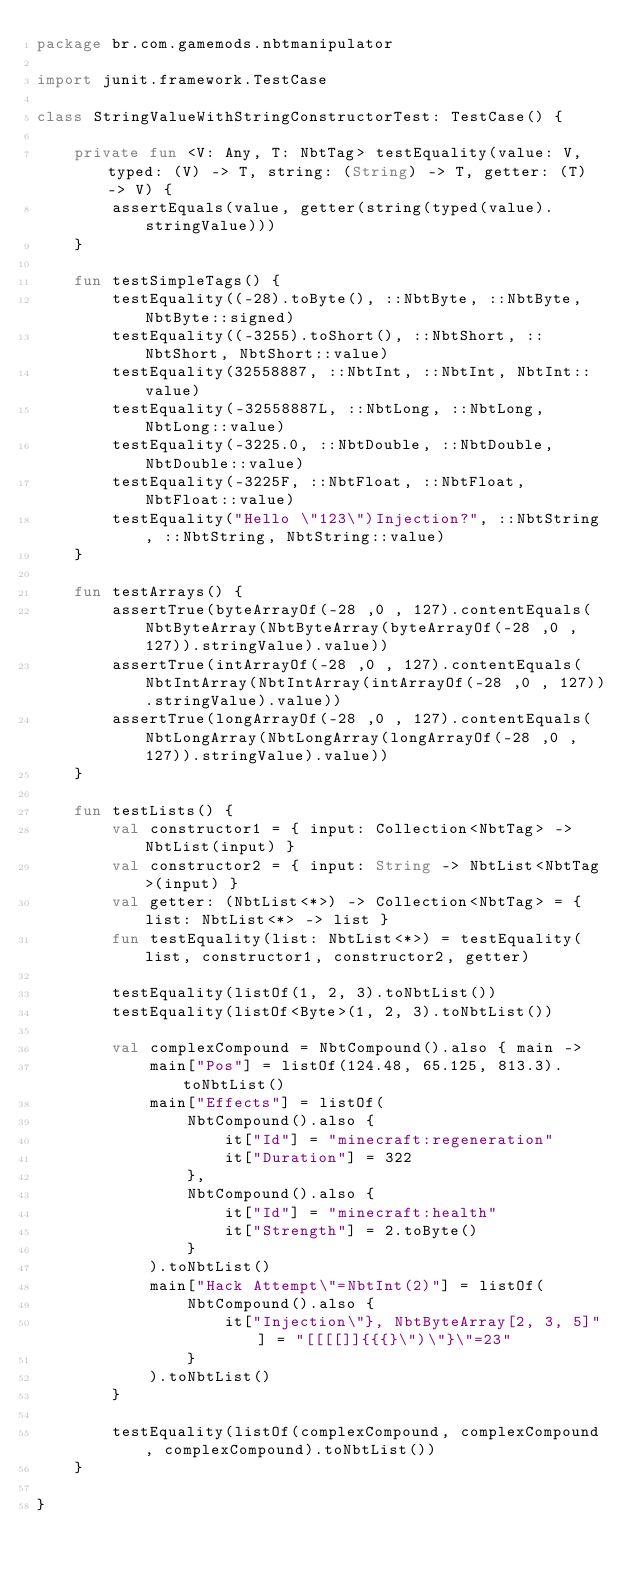<code> <loc_0><loc_0><loc_500><loc_500><_Kotlin_>package br.com.gamemods.nbtmanipulator

import junit.framework.TestCase

class StringValueWithStringConstructorTest: TestCase() {

    private fun <V: Any, T: NbtTag> testEquality(value: V, typed: (V) -> T, string: (String) -> T, getter: (T) -> V) {
        assertEquals(value, getter(string(typed(value).stringValue)))
    }

    fun testSimpleTags() {
        testEquality((-28).toByte(), ::NbtByte, ::NbtByte, NbtByte::signed)
        testEquality((-3255).toShort(), ::NbtShort, ::NbtShort, NbtShort::value)
        testEquality(32558887, ::NbtInt, ::NbtInt, NbtInt::value)
        testEquality(-32558887L, ::NbtLong, ::NbtLong, NbtLong::value)
        testEquality(-3225.0, ::NbtDouble, ::NbtDouble, NbtDouble::value)
        testEquality(-3225F, ::NbtFloat, ::NbtFloat, NbtFloat::value)
        testEquality("Hello \"123\")Injection?", ::NbtString, ::NbtString, NbtString::value)
    }

    fun testArrays() {
        assertTrue(byteArrayOf(-28 ,0 , 127).contentEquals(NbtByteArray(NbtByteArray(byteArrayOf(-28 ,0 , 127)).stringValue).value))
        assertTrue(intArrayOf(-28 ,0 , 127).contentEquals(NbtIntArray(NbtIntArray(intArrayOf(-28 ,0 , 127)).stringValue).value))
        assertTrue(longArrayOf(-28 ,0 , 127).contentEquals(NbtLongArray(NbtLongArray(longArrayOf(-28 ,0 , 127)).stringValue).value))
    }

    fun testLists() {
        val constructor1 = { input: Collection<NbtTag> -> NbtList(input) }
        val constructor2 = { input: String -> NbtList<NbtTag>(input) }
        val getter: (NbtList<*>) -> Collection<NbtTag> = { list: NbtList<*> -> list }
        fun testEquality(list: NbtList<*>) = testEquality(list, constructor1, constructor2, getter)

        testEquality(listOf(1, 2, 3).toNbtList())
        testEquality(listOf<Byte>(1, 2, 3).toNbtList())

        val complexCompound = NbtCompound().also { main ->
            main["Pos"] = listOf(124.48, 65.125, 813.3).toNbtList()
            main["Effects"] = listOf(
                NbtCompound().also {
                    it["Id"] = "minecraft:regeneration"
                    it["Duration"] = 322
                },
                NbtCompound().also {
                    it["Id"] = "minecraft:health"
                    it["Strength"] = 2.toByte()
                }
            ).toNbtList()
            main["Hack Attempt\"=NbtInt(2)"] = listOf(
                NbtCompound().also {
                    it["Injection\"}, NbtByteArray[2, 3, 5]"] = "[[[[]]{{{}\")\"}\"=23"
                }
            ).toNbtList()
        }

        testEquality(listOf(complexCompound, complexCompound, complexCompound).toNbtList())
    }

}
</code> 